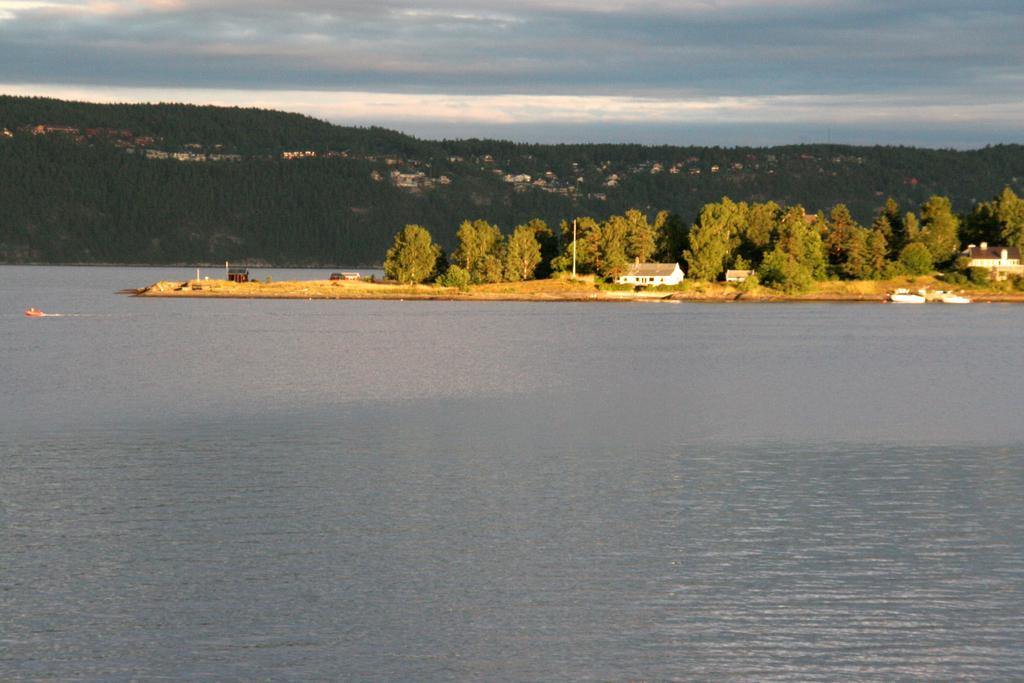Please provide a concise description of this image. In this image we can see water, boats floating on the water, we can see houses, trees, hills and the cloudy sky in the background 